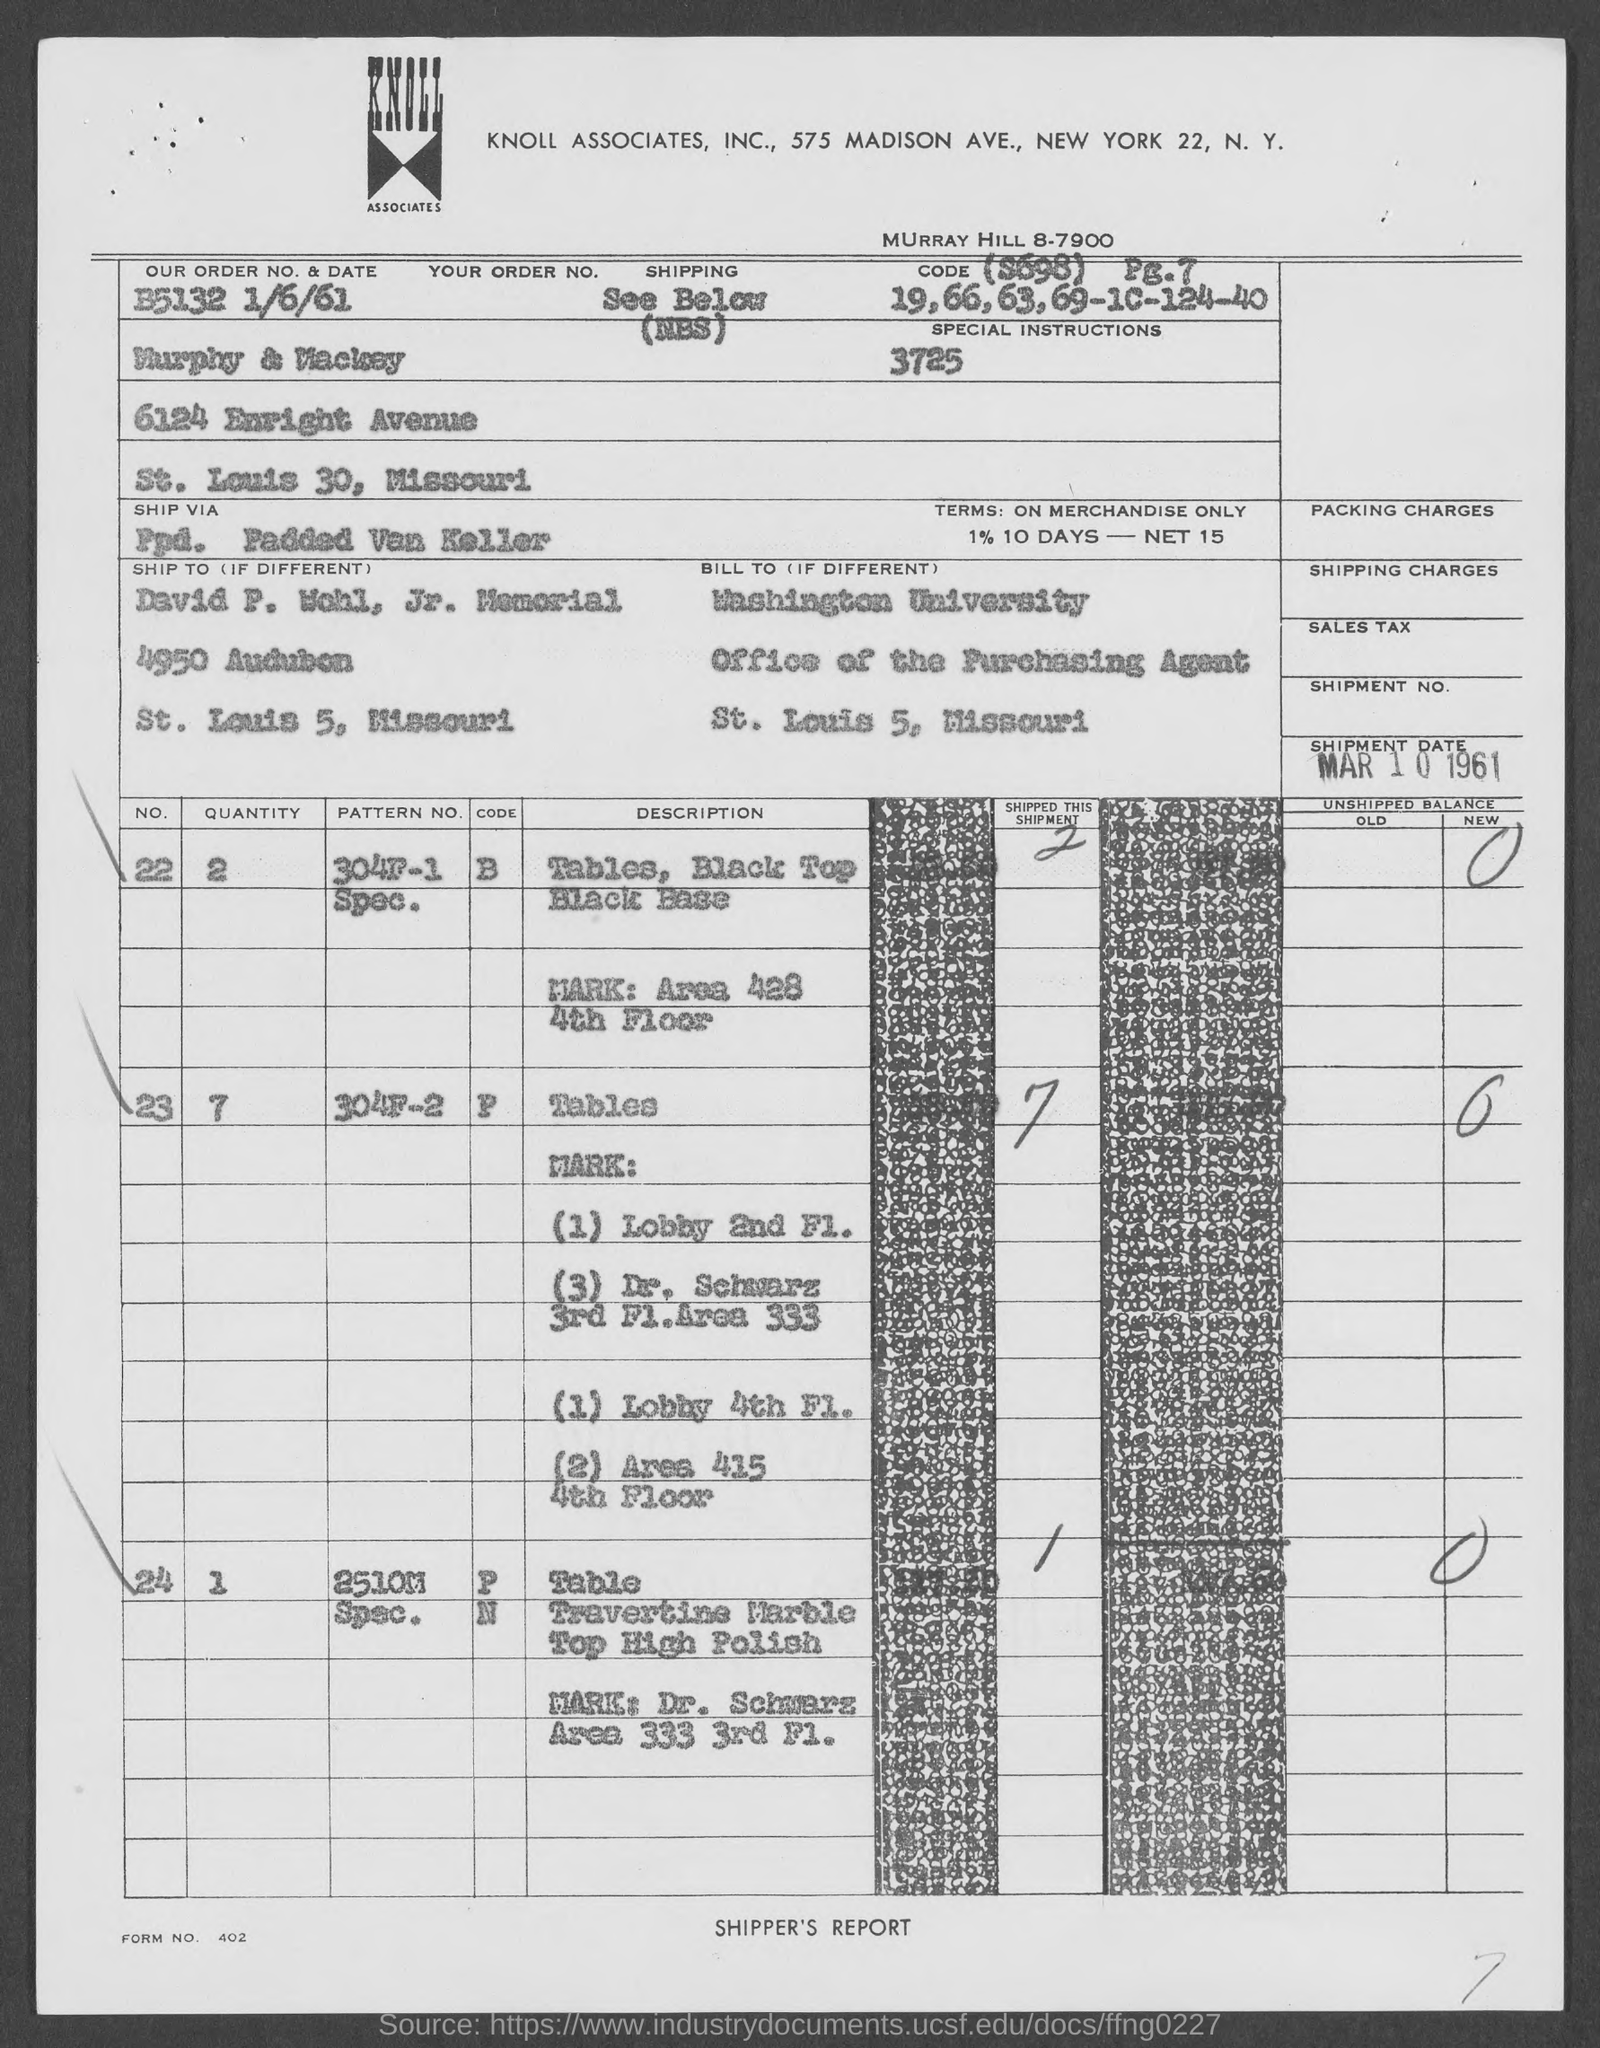Which company is mentioned in the header of the document?
Ensure brevity in your answer.  Knoll Associates. What is the Order No. & date mentioned in the dcoument?
Your response must be concise. B5132 1/6/61. What is the Shipment date given in the document?
Make the answer very short. MAR 10 1961. Which university is mentioned in the billing address?
Your response must be concise. Washington University. What is the Form No. given in the document?
Your answer should be compact. 402. 